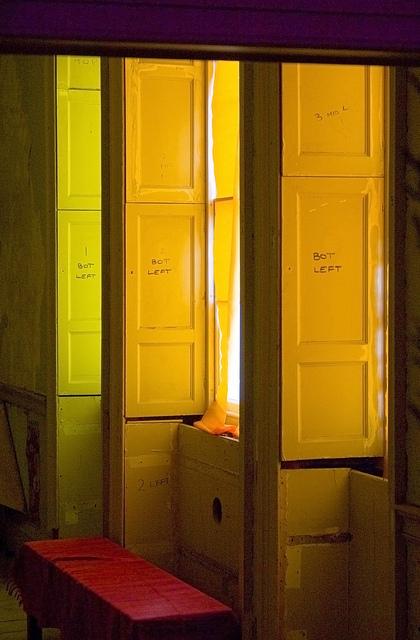What color is the bench?
Keep it brief. Red. What is red in the photo?
Keep it brief. Bench. Are these handmade cabinets?
Concise answer only. Yes. 